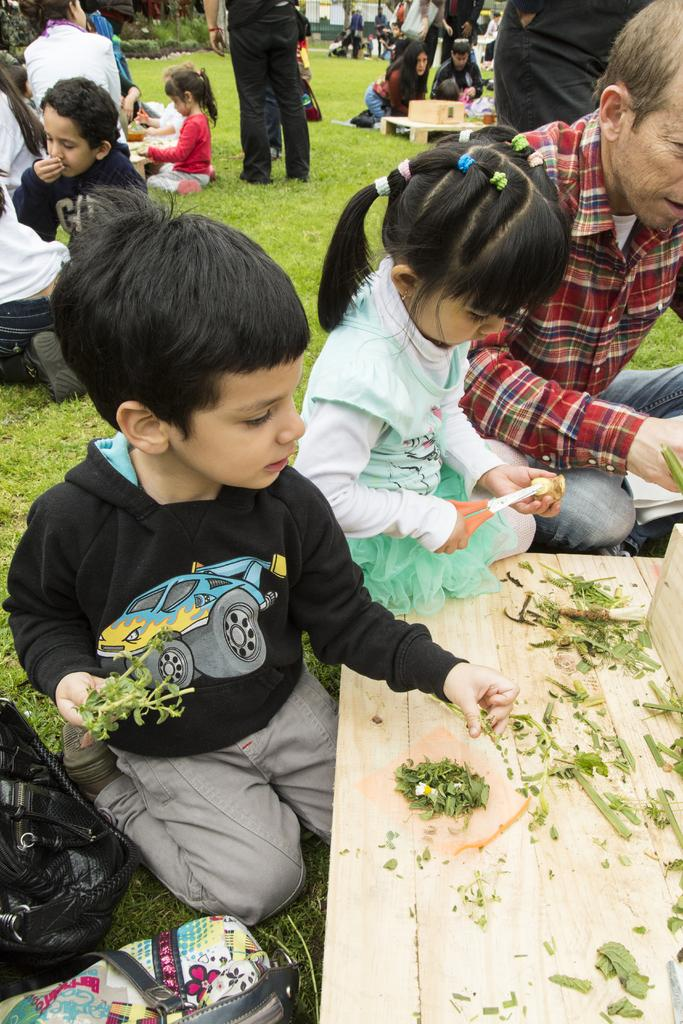What objects are present in the image? There are bags, tables, and plants visible in the image. Can you describe the people in the image? There is a group of people standing and a group of people sitting in the image. What might be on the tables in the image? There are items on the tables in the image. What type of books can be seen on the boats in the image? There are no boats or books present in the image. 